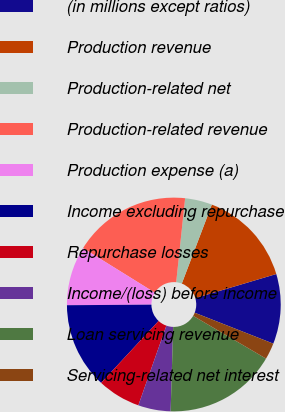<chart> <loc_0><loc_0><loc_500><loc_500><pie_chart><fcel>(in millions except ratios)<fcel>Production revenue<fcel>Production-related net<fcel>Production-related revenue<fcel>Production expense (a)<fcel>Income excluding repurchase<fcel>Repurchase losses<fcel>Income/(loss) before income<fcel>Loan servicing revenue<fcel>Servicing-related net interest<nl><fcel>10.57%<fcel>14.61%<fcel>4.1%<fcel>17.84%<fcel>8.95%<fcel>12.99%<fcel>6.52%<fcel>4.91%<fcel>17.03%<fcel>2.48%<nl></chart> 